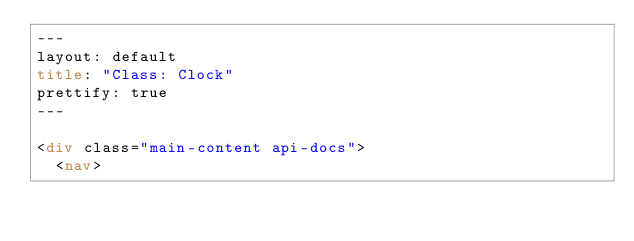Convert code to text. <code><loc_0><loc_0><loc_500><loc_500><_HTML_>---
layout: default
title: "Class: Clock"
prettify: true
---

<div class="main-content api-docs">
  <nav></code> 